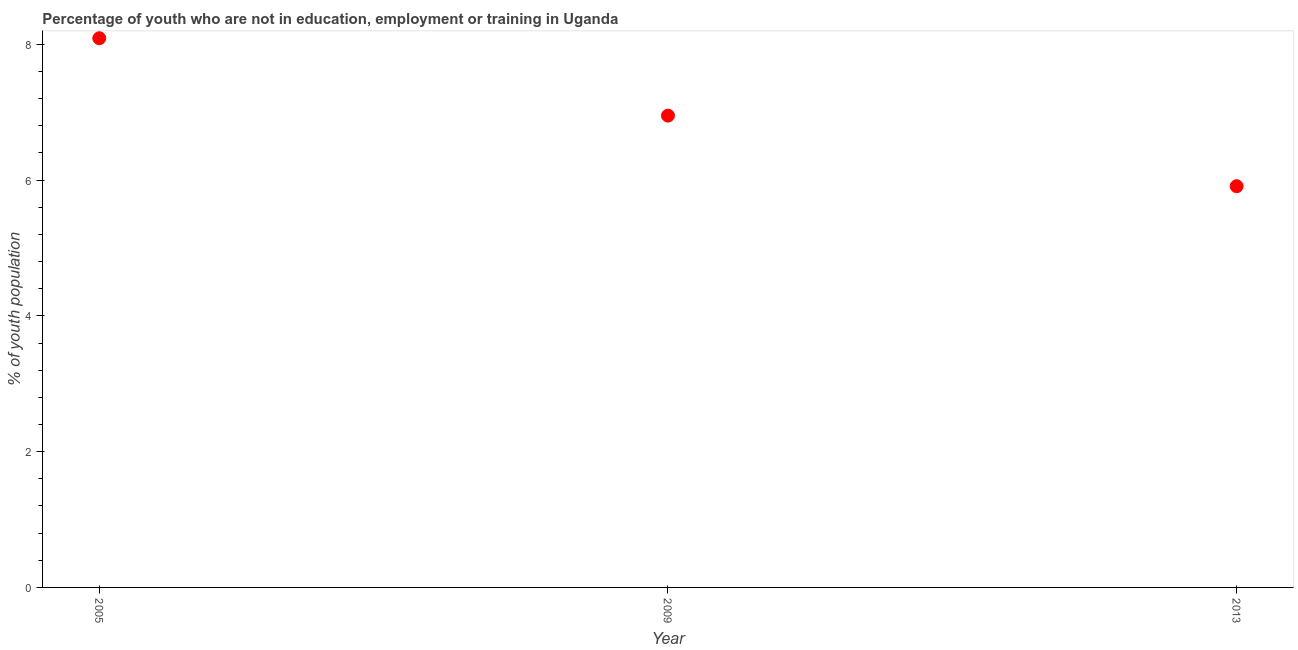What is the unemployed youth population in 2005?
Give a very brief answer. 8.09. Across all years, what is the maximum unemployed youth population?
Offer a very short reply. 8.09. Across all years, what is the minimum unemployed youth population?
Your answer should be very brief. 5.91. In which year was the unemployed youth population maximum?
Provide a short and direct response. 2005. What is the sum of the unemployed youth population?
Your response must be concise. 20.95. What is the difference between the unemployed youth population in 2009 and 2013?
Offer a very short reply. 1.04. What is the average unemployed youth population per year?
Make the answer very short. 6.98. What is the median unemployed youth population?
Your response must be concise. 6.95. In how many years, is the unemployed youth population greater than 2.4 %?
Offer a terse response. 3. Do a majority of the years between 2009 and 2005 (inclusive) have unemployed youth population greater than 0.4 %?
Offer a terse response. No. What is the ratio of the unemployed youth population in 2009 to that in 2013?
Your response must be concise. 1.18. Is the unemployed youth population in 2005 less than that in 2009?
Provide a succinct answer. No. Is the difference between the unemployed youth population in 2005 and 2013 greater than the difference between any two years?
Your response must be concise. Yes. What is the difference between the highest and the second highest unemployed youth population?
Offer a very short reply. 1.14. Is the sum of the unemployed youth population in 2005 and 2013 greater than the maximum unemployed youth population across all years?
Your answer should be compact. Yes. What is the difference between the highest and the lowest unemployed youth population?
Your response must be concise. 2.18. In how many years, is the unemployed youth population greater than the average unemployed youth population taken over all years?
Keep it short and to the point. 1. How many dotlines are there?
Give a very brief answer. 1. How many years are there in the graph?
Give a very brief answer. 3. What is the difference between two consecutive major ticks on the Y-axis?
Keep it short and to the point. 2. What is the title of the graph?
Provide a short and direct response. Percentage of youth who are not in education, employment or training in Uganda. What is the label or title of the Y-axis?
Keep it short and to the point. % of youth population. What is the % of youth population in 2005?
Provide a short and direct response. 8.09. What is the % of youth population in 2009?
Offer a very short reply. 6.95. What is the % of youth population in 2013?
Provide a short and direct response. 5.91. What is the difference between the % of youth population in 2005 and 2009?
Provide a short and direct response. 1.14. What is the difference between the % of youth population in 2005 and 2013?
Your response must be concise. 2.18. What is the difference between the % of youth population in 2009 and 2013?
Your response must be concise. 1.04. What is the ratio of the % of youth population in 2005 to that in 2009?
Your answer should be compact. 1.16. What is the ratio of the % of youth population in 2005 to that in 2013?
Give a very brief answer. 1.37. What is the ratio of the % of youth population in 2009 to that in 2013?
Ensure brevity in your answer.  1.18. 